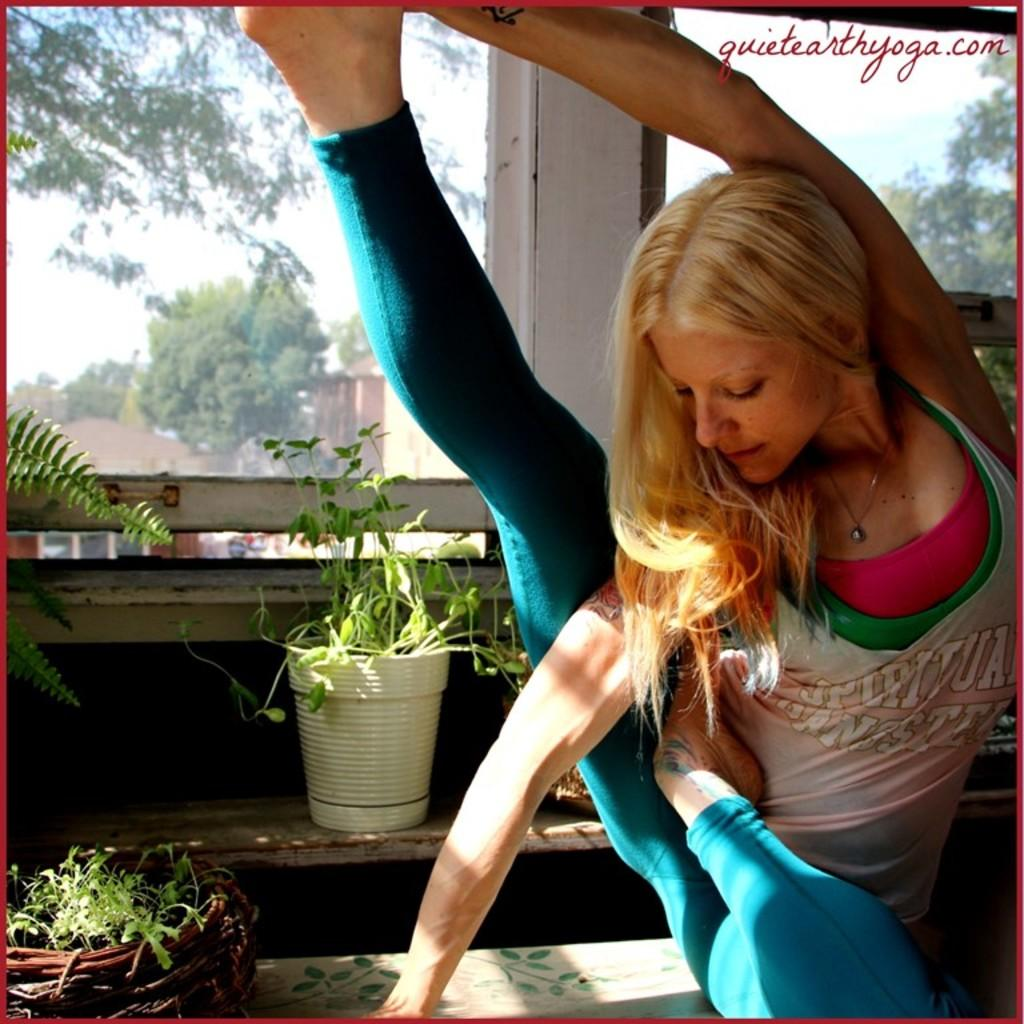Who is present in the image? There is a woman in the image. What is located beside the woman? There are plants beside the woman. What can be seen in the background of the image? There are trees and houses in the background of the image. What type of iron is being used by the woman in the image? There is no iron present in the image; the woman is not using any iron-related objects. 